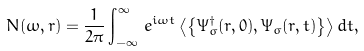<formula> <loc_0><loc_0><loc_500><loc_500>N ( \omega , r ) = \frac { 1 } { 2 \pi } \int _ { - \infty } ^ { \infty } \, e ^ { i \omega t } \left < \left \{ \Psi ^ { \dagger } _ { \sigma } ( r , 0 ) , \Psi _ { \sigma } ( r , t ) \right \} \right > d t ,</formula> 